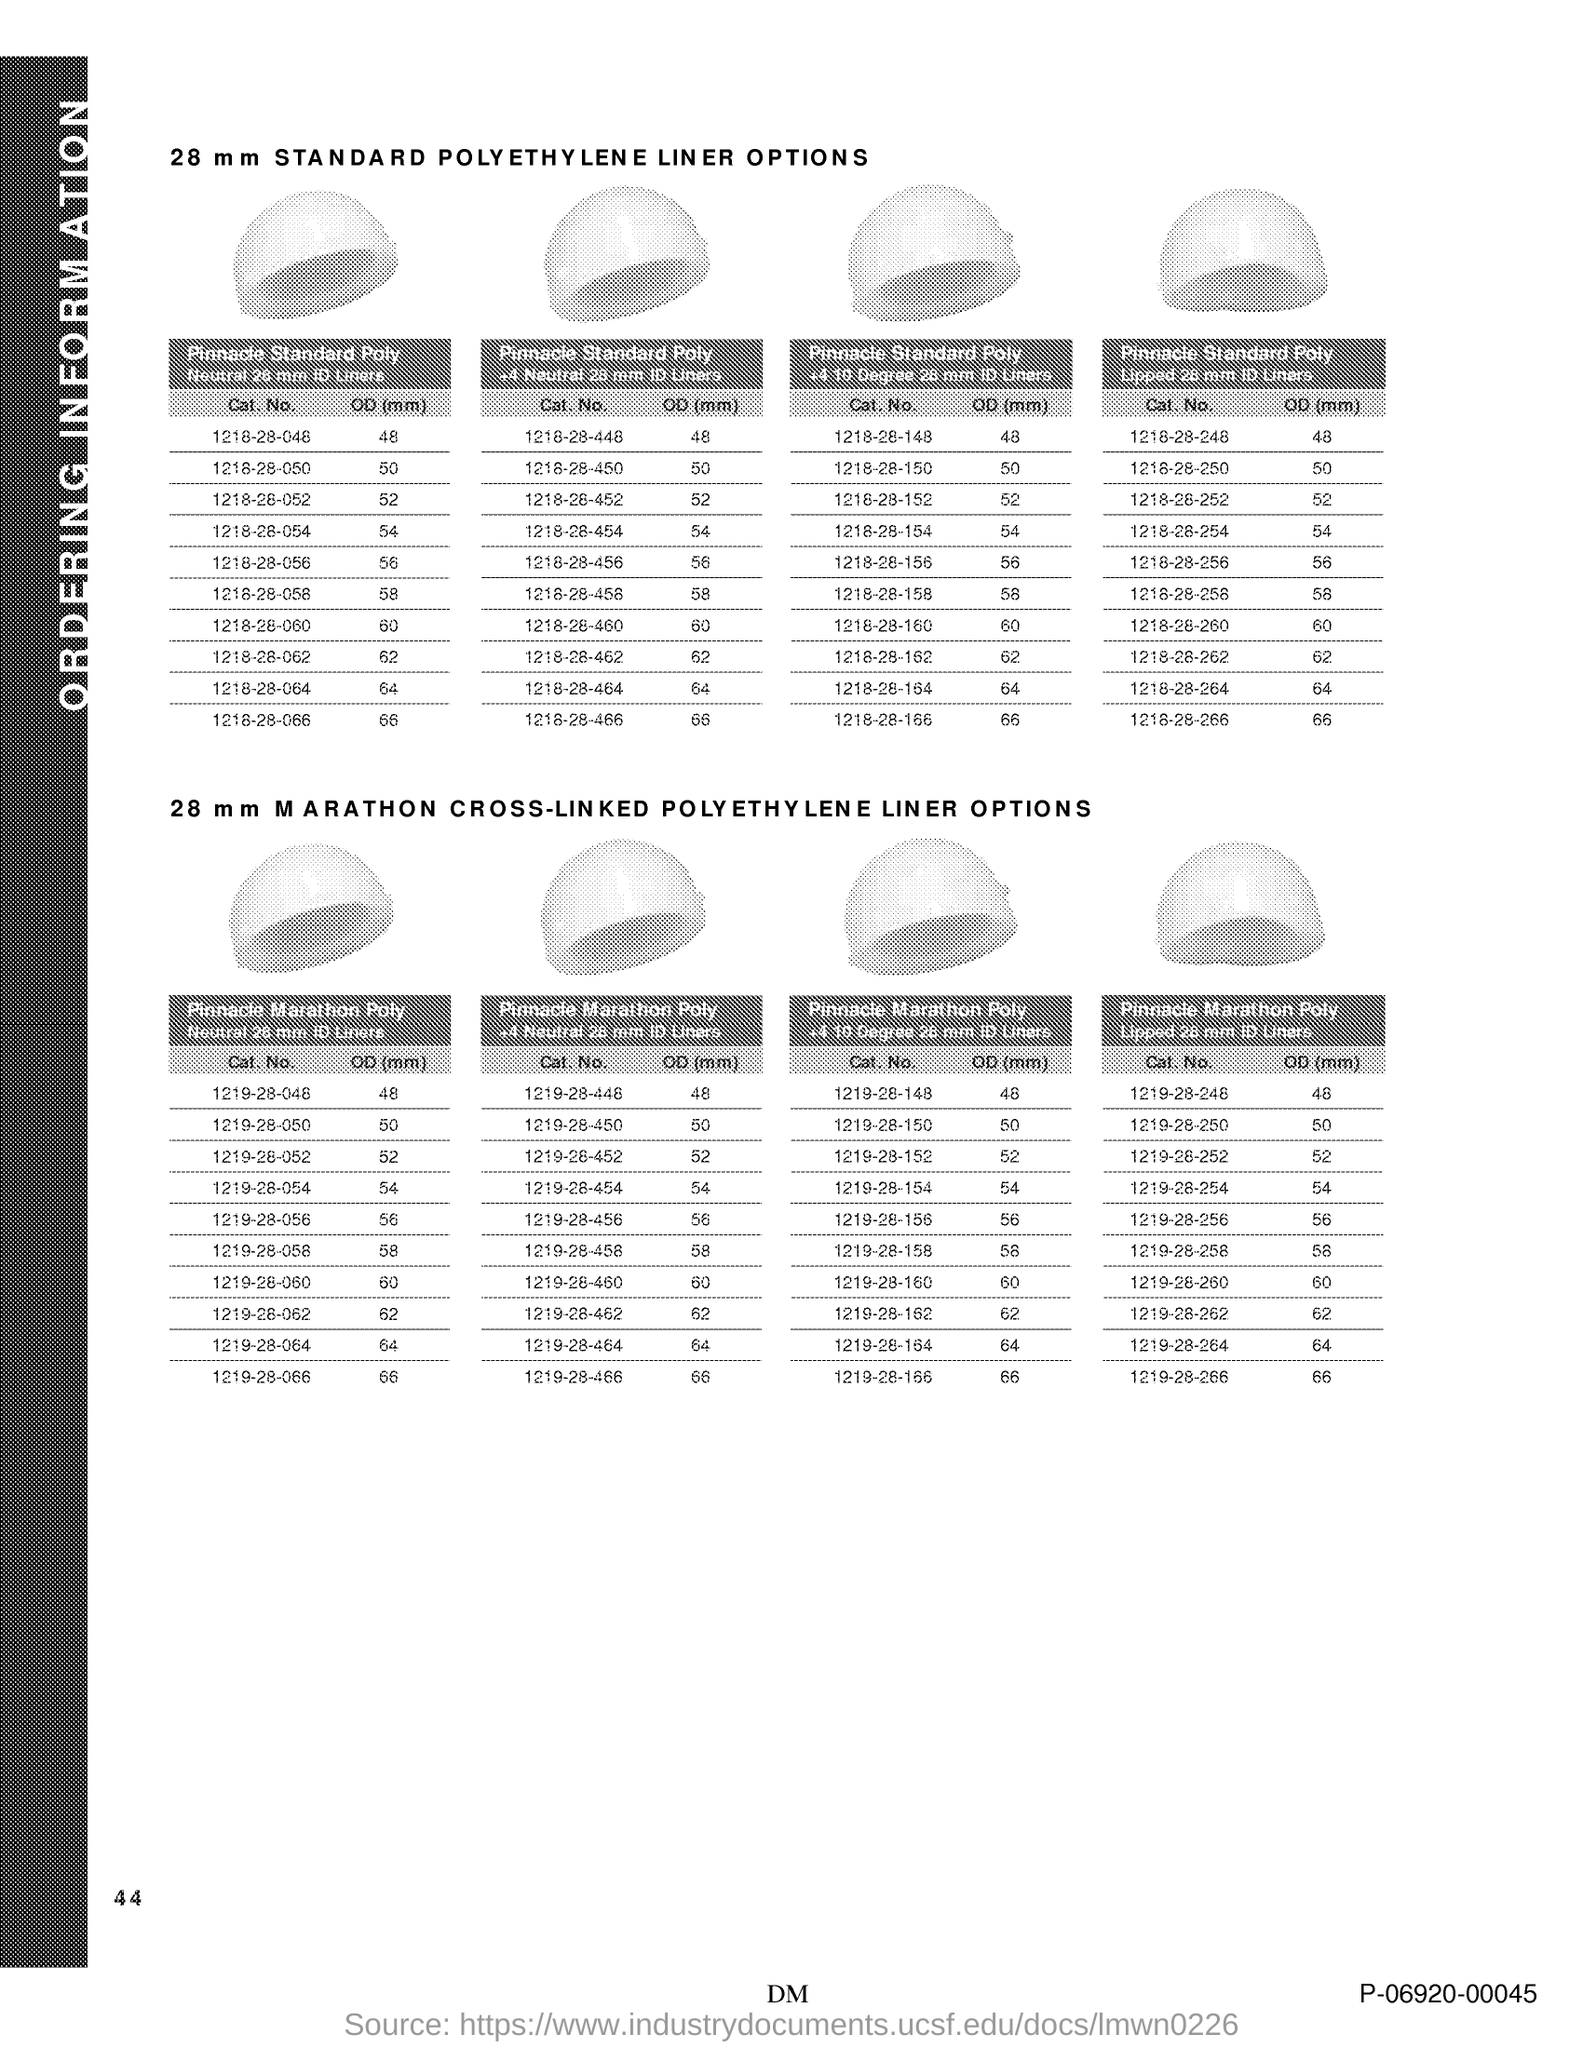What is the Page Number?
Provide a short and direct response. 44. 